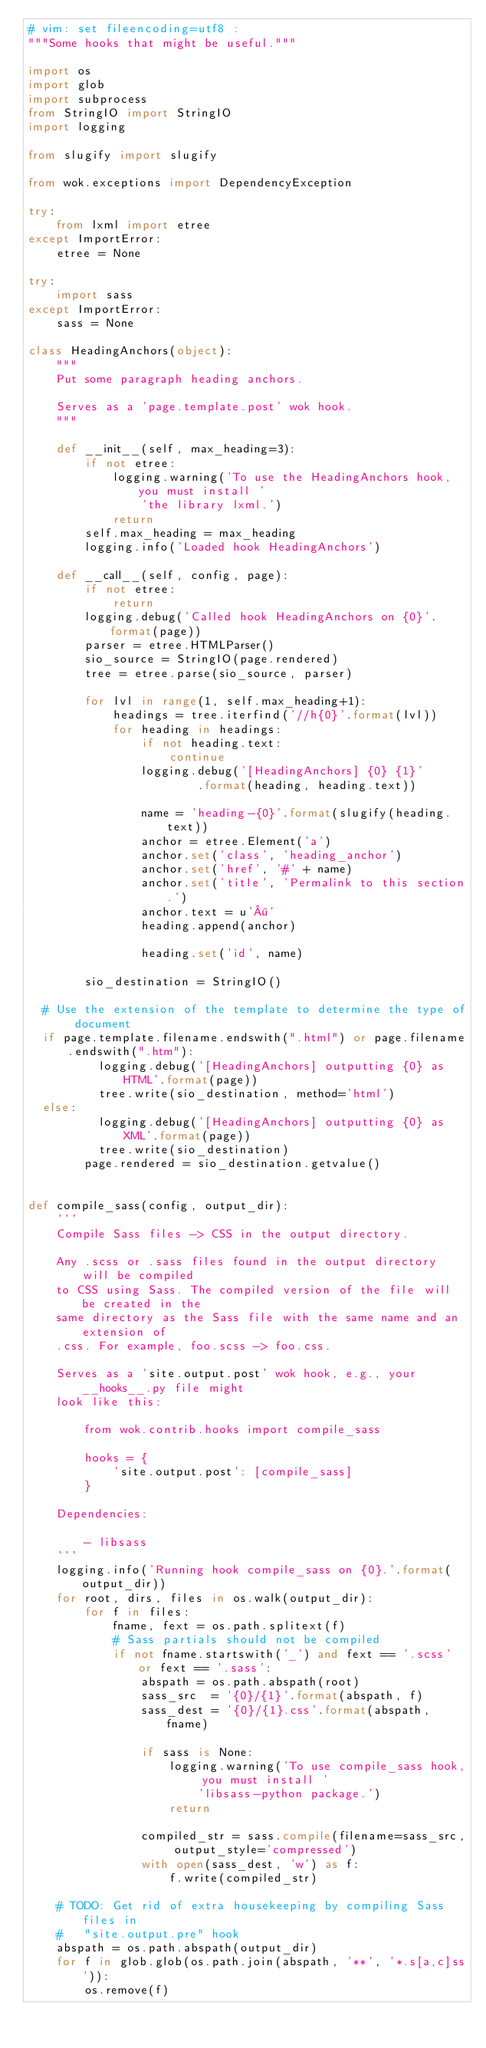Convert code to text. <code><loc_0><loc_0><loc_500><loc_500><_Python_># vim: set fileencoding=utf8 :
"""Some hooks that might be useful."""

import os
import glob
import subprocess
from StringIO import StringIO
import logging

from slugify import slugify

from wok.exceptions import DependencyException

try:
    from lxml import etree
except ImportError:
    etree = None

try:
    import sass
except ImportError:
    sass = None

class HeadingAnchors(object):
    """
    Put some paragraph heading anchors.

    Serves as a 'page.template.post' wok hook.
    """

    def __init__(self, max_heading=3):
        if not etree:
            logging.warning('To use the HeadingAnchors hook, you must install '
                'the library lxml.')
            return
        self.max_heading = max_heading
        logging.info('Loaded hook HeadingAnchors')

    def __call__(self, config, page):
        if not etree:
            return
        logging.debug('Called hook HeadingAnchors on {0}'.format(page))
        parser = etree.HTMLParser()
        sio_source = StringIO(page.rendered)
        tree = etree.parse(sio_source, parser)

        for lvl in range(1, self.max_heading+1):
            headings = tree.iterfind('//h{0}'.format(lvl))
            for heading in headings:
                if not heading.text:
                    continue
                logging.debug('[HeadingAnchors] {0} {1}'
                        .format(heading, heading.text))

                name = 'heading-{0}'.format(slugify(heading.text))
                anchor = etree.Element('a')
                anchor.set('class', 'heading_anchor')
                anchor.set('href', '#' + name)
                anchor.set('title', 'Permalink to this section.')
                anchor.text = u'¶'
                heading.append(anchor)

                heading.set('id', name)

        sio_destination = StringIO()

	# Use the extension of the template to determine the type of document
	if page.template.filename.endswith(".html") or page.filename.endswith(".htm"):
        	logging.debug('[HeadingAnchors] outputting {0} as HTML'.format(page))
	        tree.write(sio_destination, method='html')
	else:
        	logging.debug('[HeadingAnchors] outputting {0} as XML'.format(page))
	        tree.write(sio_destination)
        page.rendered = sio_destination.getvalue()


def compile_sass(config, output_dir):
    '''
    Compile Sass files -> CSS in the output directory.

    Any .scss or .sass files found in the output directory will be compiled
    to CSS using Sass. The compiled version of the file will be created in the
    same directory as the Sass file with the same name and an extension of
    .css. For example, foo.scss -> foo.css.

    Serves as a 'site.output.post' wok hook, e.g., your __hooks__.py file might
    look like this:

        from wok.contrib.hooks import compile_sass

        hooks = {
            'site.output.post': [compile_sass]
        }

    Dependencies:

        - libsass
    '''
    logging.info('Running hook compile_sass on {0}.'.format(output_dir))
    for root, dirs, files in os.walk(output_dir):
        for f in files:
            fname, fext = os.path.splitext(f)
            # Sass partials should not be compiled
            if not fname.startswith('_') and fext == '.scss' or fext == '.sass':
                abspath = os.path.abspath(root)
                sass_src  = '{0}/{1}'.format(abspath, f)
                sass_dest = '{0}/{1}.css'.format(abspath, fname)

                if sass is None:
                    logging.warning('To use compile_sass hook, you must install '
                        'libsass-python package.')
                    return

                compiled_str = sass.compile(filename=sass_src, output_style='compressed')
                with open(sass_dest, 'w') as f:
                    f.write(compiled_str)

    # TODO: Get rid of extra housekeeping by compiling Sass files in
    #   "site.output.pre" hook
    abspath = os.path.abspath(output_dir)
    for f in glob.glob(os.path.join(abspath, '**', '*.s[a,c]ss')):
        os.remove(f)
</code> 